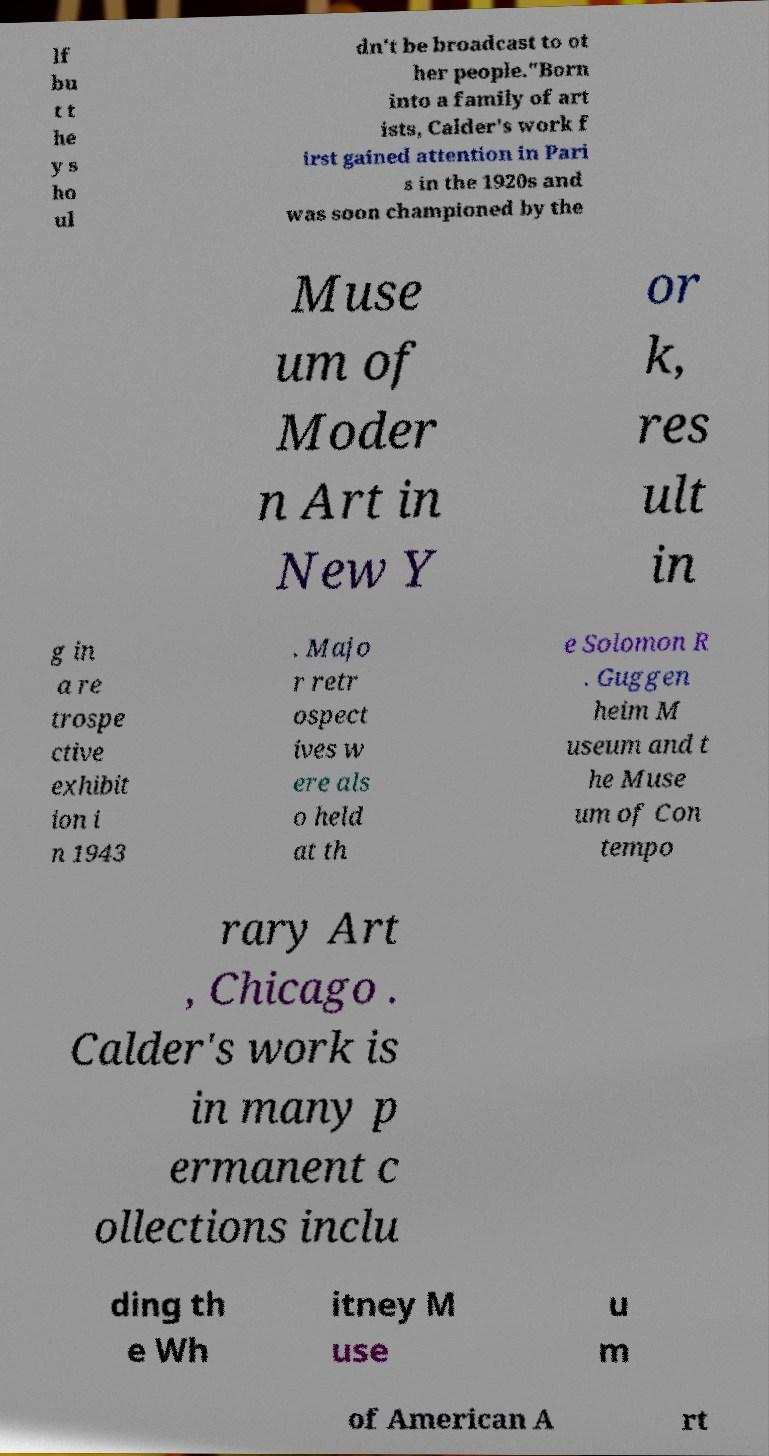For documentation purposes, I need the text within this image transcribed. Could you provide that? lf bu t t he y s ho ul dn't be broadcast to ot her people."Born into a family of art ists, Calder's work f irst gained attention in Pari s in the 1920s and was soon championed by the Muse um of Moder n Art in New Y or k, res ult in g in a re trospe ctive exhibit ion i n 1943 . Majo r retr ospect ives w ere als o held at th e Solomon R . Guggen heim M useum and t he Muse um of Con tempo rary Art , Chicago . Calder's work is in many p ermanent c ollections inclu ding th e Wh itney M use u m of American A rt 